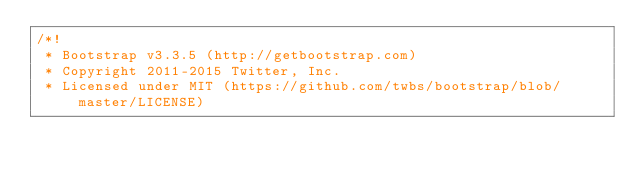Convert code to text. <code><loc_0><loc_0><loc_500><loc_500><_CSS_>/*!
 * Bootstrap v3.3.5 (http://getbootstrap.com)
 * Copyright 2011-2015 Twitter, Inc.
 * Licensed under MIT (https://github.com/twbs/bootstrap/blob/master/LICENSE)</code> 